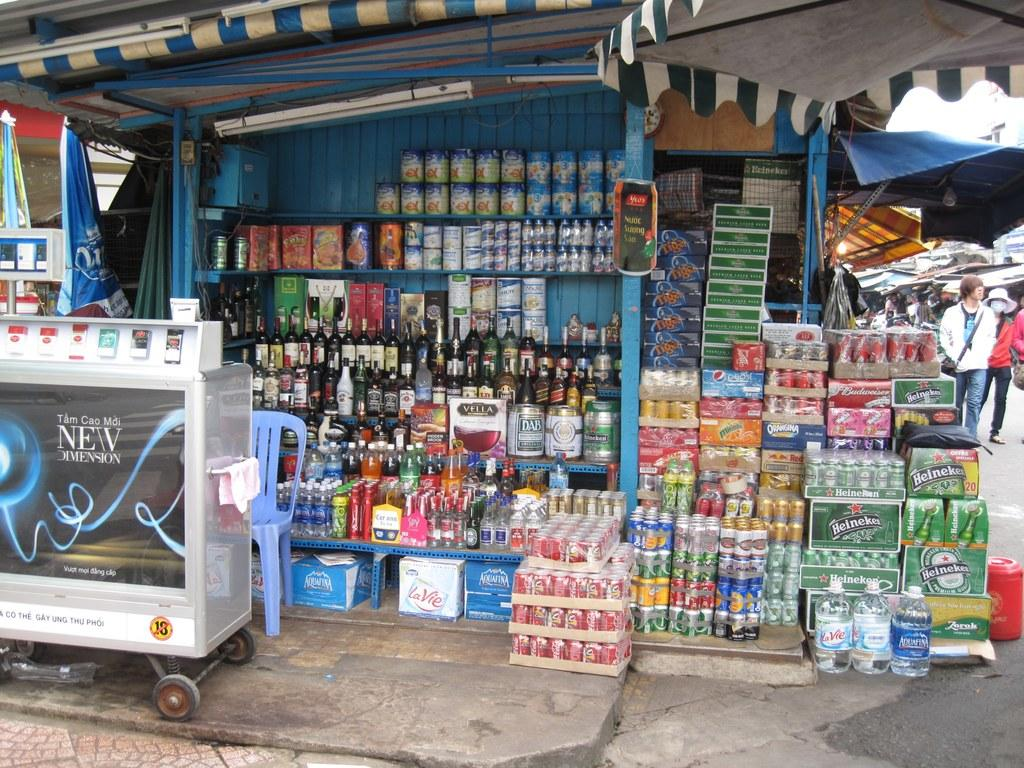<image>
Provide a brief description of the given image. Large display of alcohol outdoors including boxes of Heineken. 